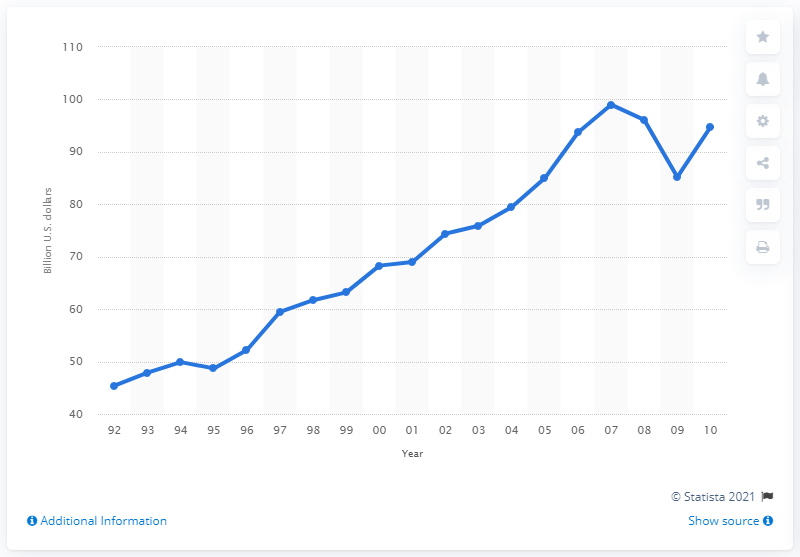Outline some significant characteristics in this image. In 2007, a total of $99 was spent on apparel, piece goods, and notions purchases in the United States. 